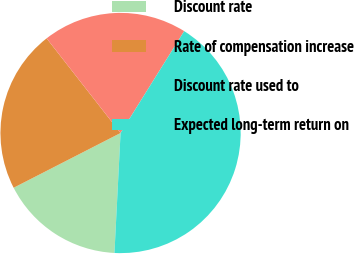<chart> <loc_0><loc_0><loc_500><loc_500><pie_chart><fcel>Discount rate<fcel>Rate of compensation increase<fcel>Discount rate used to<fcel>Expected long-term return on<nl><fcel>16.66%<fcel>21.98%<fcel>19.44%<fcel>41.93%<nl></chart> 